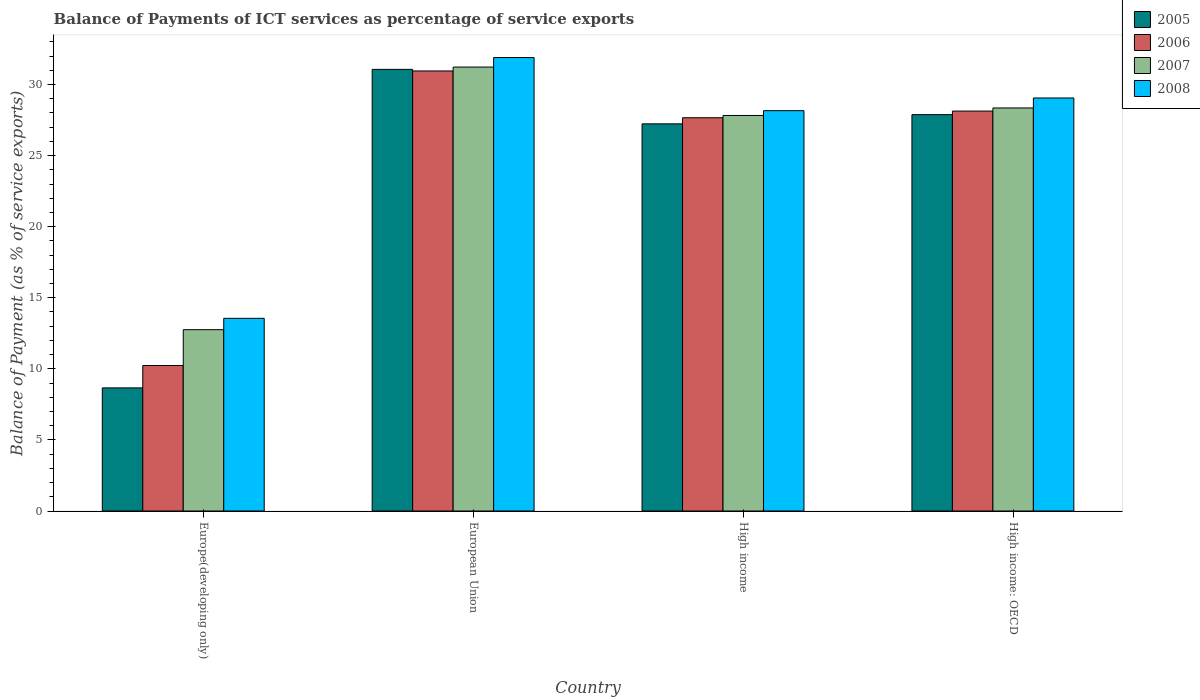How many groups of bars are there?
Your response must be concise. 4. How many bars are there on the 3rd tick from the right?
Provide a short and direct response. 4. In how many cases, is the number of bars for a given country not equal to the number of legend labels?
Offer a very short reply. 0. What is the balance of payments of ICT services in 2005 in High income: OECD?
Your answer should be compact. 27.88. Across all countries, what is the maximum balance of payments of ICT services in 2005?
Ensure brevity in your answer.  31.07. Across all countries, what is the minimum balance of payments of ICT services in 2006?
Keep it short and to the point. 10.24. In which country was the balance of payments of ICT services in 2006 minimum?
Make the answer very short. Europe(developing only). What is the total balance of payments of ICT services in 2005 in the graph?
Provide a succinct answer. 94.85. What is the difference between the balance of payments of ICT services in 2006 in Europe(developing only) and that in High income: OECD?
Provide a succinct answer. -17.9. What is the difference between the balance of payments of ICT services in 2006 in High income and the balance of payments of ICT services in 2007 in European Union?
Provide a succinct answer. -3.56. What is the average balance of payments of ICT services in 2008 per country?
Your response must be concise. 25.67. What is the difference between the balance of payments of ICT services of/in 2005 and balance of payments of ICT services of/in 2007 in Europe(developing only)?
Your response must be concise. -4.1. In how many countries, is the balance of payments of ICT services in 2008 greater than 9 %?
Your response must be concise. 4. What is the ratio of the balance of payments of ICT services in 2007 in European Union to that in High income?
Your answer should be compact. 1.12. What is the difference between the highest and the second highest balance of payments of ICT services in 2006?
Provide a succinct answer. -0.47. What is the difference between the highest and the lowest balance of payments of ICT services in 2006?
Give a very brief answer. 20.72. What does the 1st bar from the left in Europe(developing only) represents?
Your answer should be very brief. 2005. Are all the bars in the graph horizontal?
Provide a succinct answer. No. What is the difference between two consecutive major ticks on the Y-axis?
Provide a succinct answer. 5. Are the values on the major ticks of Y-axis written in scientific E-notation?
Make the answer very short. No. Does the graph contain grids?
Your answer should be very brief. No. Where does the legend appear in the graph?
Make the answer very short. Top right. How many legend labels are there?
Provide a succinct answer. 4. What is the title of the graph?
Keep it short and to the point. Balance of Payments of ICT services as percentage of service exports. Does "1970" appear as one of the legend labels in the graph?
Keep it short and to the point. No. What is the label or title of the Y-axis?
Your answer should be very brief. Balance of Payment (as % of service exports). What is the Balance of Payment (as % of service exports) of 2005 in Europe(developing only)?
Your response must be concise. 8.66. What is the Balance of Payment (as % of service exports) in 2006 in Europe(developing only)?
Provide a short and direct response. 10.24. What is the Balance of Payment (as % of service exports) in 2007 in Europe(developing only)?
Your response must be concise. 12.76. What is the Balance of Payment (as % of service exports) in 2008 in Europe(developing only)?
Provide a short and direct response. 13.56. What is the Balance of Payment (as % of service exports) of 2005 in European Union?
Give a very brief answer. 31.07. What is the Balance of Payment (as % of service exports) in 2006 in European Union?
Your answer should be compact. 30.96. What is the Balance of Payment (as % of service exports) in 2007 in European Union?
Your response must be concise. 31.23. What is the Balance of Payment (as % of service exports) of 2008 in European Union?
Offer a terse response. 31.9. What is the Balance of Payment (as % of service exports) of 2005 in High income?
Your answer should be compact. 27.24. What is the Balance of Payment (as % of service exports) in 2006 in High income?
Make the answer very short. 27.67. What is the Balance of Payment (as % of service exports) in 2007 in High income?
Provide a short and direct response. 27.83. What is the Balance of Payment (as % of service exports) in 2008 in High income?
Your answer should be compact. 28.16. What is the Balance of Payment (as % of service exports) in 2005 in High income: OECD?
Offer a terse response. 27.88. What is the Balance of Payment (as % of service exports) of 2006 in High income: OECD?
Your answer should be compact. 28.13. What is the Balance of Payment (as % of service exports) in 2007 in High income: OECD?
Your response must be concise. 28.35. What is the Balance of Payment (as % of service exports) in 2008 in High income: OECD?
Give a very brief answer. 29.06. Across all countries, what is the maximum Balance of Payment (as % of service exports) in 2005?
Your response must be concise. 31.07. Across all countries, what is the maximum Balance of Payment (as % of service exports) in 2006?
Your answer should be compact. 30.96. Across all countries, what is the maximum Balance of Payment (as % of service exports) in 2007?
Your answer should be compact. 31.23. Across all countries, what is the maximum Balance of Payment (as % of service exports) of 2008?
Your response must be concise. 31.9. Across all countries, what is the minimum Balance of Payment (as % of service exports) in 2005?
Make the answer very short. 8.66. Across all countries, what is the minimum Balance of Payment (as % of service exports) in 2006?
Your answer should be very brief. 10.24. Across all countries, what is the minimum Balance of Payment (as % of service exports) in 2007?
Provide a short and direct response. 12.76. Across all countries, what is the minimum Balance of Payment (as % of service exports) of 2008?
Ensure brevity in your answer.  13.56. What is the total Balance of Payment (as % of service exports) in 2005 in the graph?
Make the answer very short. 94.85. What is the total Balance of Payment (as % of service exports) in 2006 in the graph?
Offer a terse response. 96.99. What is the total Balance of Payment (as % of service exports) of 2007 in the graph?
Ensure brevity in your answer.  100.17. What is the total Balance of Payment (as % of service exports) of 2008 in the graph?
Your answer should be very brief. 102.68. What is the difference between the Balance of Payment (as % of service exports) in 2005 in Europe(developing only) and that in European Union?
Your answer should be compact. -22.41. What is the difference between the Balance of Payment (as % of service exports) of 2006 in Europe(developing only) and that in European Union?
Give a very brief answer. -20.72. What is the difference between the Balance of Payment (as % of service exports) in 2007 in Europe(developing only) and that in European Union?
Your answer should be compact. -18.47. What is the difference between the Balance of Payment (as % of service exports) of 2008 in Europe(developing only) and that in European Union?
Your response must be concise. -18.35. What is the difference between the Balance of Payment (as % of service exports) in 2005 in Europe(developing only) and that in High income?
Your response must be concise. -18.57. What is the difference between the Balance of Payment (as % of service exports) of 2006 in Europe(developing only) and that in High income?
Offer a very short reply. -17.43. What is the difference between the Balance of Payment (as % of service exports) of 2007 in Europe(developing only) and that in High income?
Give a very brief answer. -15.07. What is the difference between the Balance of Payment (as % of service exports) of 2008 in Europe(developing only) and that in High income?
Make the answer very short. -14.61. What is the difference between the Balance of Payment (as % of service exports) of 2005 in Europe(developing only) and that in High income: OECD?
Provide a short and direct response. -19.22. What is the difference between the Balance of Payment (as % of service exports) of 2006 in Europe(developing only) and that in High income: OECD?
Keep it short and to the point. -17.9. What is the difference between the Balance of Payment (as % of service exports) of 2007 in Europe(developing only) and that in High income: OECD?
Offer a very short reply. -15.6. What is the difference between the Balance of Payment (as % of service exports) in 2008 in Europe(developing only) and that in High income: OECD?
Offer a very short reply. -15.5. What is the difference between the Balance of Payment (as % of service exports) in 2005 in European Union and that in High income?
Give a very brief answer. 3.83. What is the difference between the Balance of Payment (as % of service exports) of 2006 in European Union and that in High income?
Your response must be concise. 3.29. What is the difference between the Balance of Payment (as % of service exports) of 2007 in European Union and that in High income?
Give a very brief answer. 3.41. What is the difference between the Balance of Payment (as % of service exports) in 2008 in European Union and that in High income?
Your answer should be very brief. 3.74. What is the difference between the Balance of Payment (as % of service exports) in 2005 in European Union and that in High income: OECD?
Offer a very short reply. 3.19. What is the difference between the Balance of Payment (as % of service exports) of 2006 in European Union and that in High income: OECD?
Provide a short and direct response. 2.82. What is the difference between the Balance of Payment (as % of service exports) of 2007 in European Union and that in High income: OECD?
Offer a very short reply. 2.88. What is the difference between the Balance of Payment (as % of service exports) of 2008 in European Union and that in High income: OECD?
Make the answer very short. 2.84. What is the difference between the Balance of Payment (as % of service exports) of 2005 in High income and that in High income: OECD?
Keep it short and to the point. -0.65. What is the difference between the Balance of Payment (as % of service exports) of 2006 in High income and that in High income: OECD?
Offer a very short reply. -0.47. What is the difference between the Balance of Payment (as % of service exports) in 2007 in High income and that in High income: OECD?
Ensure brevity in your answer.  -0.53. What is the difference between the Balance of Payment (as % of service exports) in 2008 in High income and that in High income: OECD?
Keep it short and to the point. -0.89. What is the difference between the Balance of Payment (as % of service exports) in 2005 in Europe(developing only) and the Balance of Payment (as % of service exports) in 2006 in European Union?
Keep it short and to the point. -22.3. What is the difference between the Balance of Payment (as % of service exports) of 2005 in Europe(developing only) and the Balance of Payment (as % of service exports) of 2007 in European Union?
Offer a very short reply. -22.57. What is the difference between the Balance of Payment (as % of service exports) of 2005 in Europe(developing only) and the Balance of Payment (as % of service exports) of 2008 in European Union?
Give a very brief answer. -23.24. What is the difference between the Balance of Payment (as % of service exports) of 2006 in Europe(developing only) and the Balance of Payment (as % of service exports) of 2007 in European Union?
Ensure brevity in your answer.  -21. What is the difference between the Balance of Payment (as % of service exports) of 2006 in Europe(developing only) and the Balance of Payment (as % of service exports) of 2008 in European Union?
Give a very brief answer. -21.66. What is the difference between the Balance of Payment (as % of service exports) of 2007 in Europe(developing only) and the Balance of Payment (as % of service exports) of 2008 in European Union?
Make the answer very short. -19.14. What is the difference between the Balance of Payment (as % of service exports) in 2005 in Europe(developing only) and the Balance of Payment (as % of service exports) in 2006 in High income?
Your response must be concise. -19.01. What is the difference between the Balance of Payment (as % of service exports) in 2005 in Europe(developing only) and the Balance of Payment (as % of service exports) in 2007 in High income?
Your answer should be compact. -19.16. What is the difference between the Balance of Payment (as % of service exports) of 2005 in Europe(developing only) and the Balance of Payment (as % of service exports) of 2008 in High income?
Make the answer very short. -19.5. What is the difference between the Balance of Payment (as % of service exports) of 2006 in Europe(developing only) and the Balance of Payment (as % of service exports) of 2007 in High income?
Provide a short and direct response. -17.59. What is the difference between the Balance of Payment (as % of service exports) in 2006 in Europe(developing only) and the Balance of Payment (as % of service exports) in 2008 in High income?
Provide a succinct answer. -17.93. What is the difference between the Balance of Payment (as % of service exports) of 2007 in Europe(developing only) and the Balance of Payment (as % of service exports) of 2008 in High income?
Give a very brief answer. -15.41. What is the difference between the Balance of Payment (as % of service exports) of 2005 in Europe(developing only) and the Balance of Payment (as % of service exports) of 2006 in High income: OECD?
Your answer should be very brief. -19.47. What is the difference between the Balance of Payment (as % of service exports) of 2005 in Europe(developing only) and the Balance of Payment (as % of service exports) of 2007 in High income: OECD?
Provide a succinct answer. -19.69. What is the difference between the Balance of Payment (as % of service exports) in 2005 in Europe(developing only) and the Balance of Payment (as % of service exports) in 2008 in High income: OECD?
Offer a terse response. -20.39. What is the difference between the Balance of Payment (as % of service exports) in 2006 in Europe(developing only) and the Balance of Payment (as % of service exports) in 2007 in High income: OECD?
Offer a terse response. -18.12. What is the difference between the Balance of Payment (as % of service exports) of 2006 in Europe(developing only) and the Balance of Payment (as % of service exports) of 2008 in High income: OECD?
Keep it short and to the point. -18.82. What is the difference between the Balance of Payment (as % of service exports) of 2007 in Europe(developing only) and the Balance of Payment (as % of service exports) of 2008 in High income: OECD?
Keep it short and to the point. -16.3. What is the difference between the Balance of Payment (as % of service exports) of 2005 in European Union and the Balance of Payment (as % of service exports) of 2006 in High income?
Ensure brevity in your answer.  3.4. What is the difference between the Balance of Payment (as % of service exports) in 2005 in European Union and the Balance of Payment (as % of service exports) in 2007 in High income?
Provide a short and direct response. 3.24. What is the difference between the Balance of Payment (as % of service exports) in 2005 in European Union and the Balance of Payment (as % of service exports) in 2008 in High income?
Offer a very short reply. 2.91. What is the difference between the Balance of Payment (as % of service exports) of 2006 in European Union and the Balance of Payment (as % of service exports) of 2007 in High income?
Offer a very short reply. 3.13. What is the difference between the Balance of Payment (as % of service exports) in 2006 in European Union and the Balance of Payment (as % of service exports) in 2008 in High income?
Make the answer very short. 2.79. What is the difference between the Balance of Payment (as % of service exports) in 2007 in European Union and the Balance of Payment (as % of service exports) in 2008 in High income?
Your answer should be compact. 3.07. What is the difference between the Balance of Payment (as % of service exports) of 2005 in European Union and the Balance of Payment (as % of service exports) of 2006 in High income: OECD?
Make the answer very short. 2.93. What is the difference between the Balance of Payment (as % of service exports) in 2005 in European Union and the Balance of Payment (as % of service exports) in 2007 in High income: OECD?
Keep it short and to the point. 2.72. What is the difference between the Balance of Payment (as % of service exports) in 2005 in European Union and the Balance of Payment (as % of service exports) in 2008 in High income: OECD?
Offer a very short reply. 2.01. What is the difference between the Balance of Payment (as % of service exports) in 2006 in European Union and the Balance of Payment (as % of service exports) in 2007 in High income: OECD?
Ensure brevity in your answer.  2.6. What is the difference between the Balance of Payment (as % of service exports) of 2006 in European Union and the Balance of Payment (as % of service exports) of 2008 in High income: OECD?
Ensure brevity in your answer.  1.9. What is the difference between the Balance of Payment (as % of service exports) of 2007 in European Union and the Balance of Payment (as % of service exports) of 2008 in High income: OECD?
Keep it short and to the point. 2.18. What is the difference between the Balance of Payment (as % of service exports) in 2005 in High income and the Balance of Payment (as % of service exports) in 2006 in High income: OECD?
Your answer should be compact. -0.9. What is the difference between the Balance of Payment (as % of service exports) of 2005 in High income and the Balance of Payment (as % of service exports) of 2007 in High income: OECD?
Offer a very short reply. -1.12. What is the difference between the Balance of Payment (as % of service exports) of 2005 in High income and the Balance of Payment (as % of service exports) of 2008 in High income: OECD?
Your answer should be compact. -1.82. What is the difference between the Balance of Payment (as % of service exports) of 2006 in High income and the Balance of Payment (as % of service exports) of 2007 in High income: OECD?
Your answer should be very brief. -0.69. What is the difference between the Balance of Payment (as % of service exports) in 2006 in High income and the Balance of Payment (as % of service exports) in 2008 in High income: OECD?
Make the answer very short. -1.39. What is the difference between the Balance of Payment (as % of service exports) of 2007 in High income and the Balance of Payment (as % of service exports) of 2008 in High income: OECD?
Offer a very short reply. -1.23. What is the average Balance of Payment (as % of service exports) of 2005 per country?
Your answer should be very brief. 23.71. What is the average Balance of Payment (as % of service exports) in 2006 per country?
Make the answer very short. 24.25. What is the average Balance of Payment (as % of service exports) of 2007 per country?
Your answer should be compact. 25.04. What is the average Balance of Payment (as % of service exports) in 2008 per country?
Your answer should be compact. 25.67. What is the difference between the Balance of Payment (as % of service exports) in 2005 and Balance of Payment (as % of service exports) in 2006 in Europe(developing only)?
Provide a short and direct response. -1.57. What is the difference between the Balance of Payment (as % of service exports) in 2005 and Balance of Payment (as % of service exports) in 2007 in Europe(developing only)?
Give a very brief answer. -4.1. What is the difference between the Balance of Payment (as % of service exports) of 2005 and Balance of Payment (as % of service exports) of 2008 in Europe(developing only)?
Give a very brief answer. -4.89. What is the difference between the Balance of Payment (as % of service exports) of 2006 and Balance of Payment (as % of service exports) of 2007 in Europe(developing only)?
Give a very brief answer. -2.52. What is the difference between the Balance of Payment (as % of service exports) of 2006 and Balance of Payment (as % of service exports) of 2008 in Europe(developing only)?
Offer a very short reply. -3.32. What is the difference between the Balance of Payment (as % of service exports) in 2007 and Balance of Payment (as % of service exports) in 2008 in Europe(developing only)?
Provide a short and direct response. -0.8. What is the difference between the Balance of Payment (as % of service exports) in 2005 and Balance of Payment (as % of service exports) in 2006 in European Union?
Offer a terse response. 0.11. What is the difference between the Balance of Payment (as % of service exports) in 2005 and Balance of Payment (as % of service exports) in 2007 in European Union?
Provide a succinct answer. -0.16. What is the difference between the Balance of Payment (as % of service exports) in 2005 and Balance of Payment (as % of service exports) in 2008 in European Union?
Offer a very short reply. -0.83. What is the difference between the Balance of Payment (as % of service exports) of 2006 and Balance of Payment (as % of service exports) of 2007 in European Union?
Provide a short and direct response. -0.27. What is the difference between the Balance of Payment (as % of service exports) in 2006 and Balance of Payment (as % of service exports) in 2008 in European Union?
Make the answer very short. -0.94. What is the difference between the Balance of Payment (as % of service exports) in 2007 and Balance of Payment (as % of service exports) in 2008 in European Union?
Ensure brevity in your answer.  -0.67. What is the difference between the Balance of Payment (as % of service exports) in 2005 and Balance of Payment (as % of service exports) in 2006 in High income?
Offer a terse response. -0.43. What is the difference between the Balance of Payment (as % of service exports) of 2005 and Balance of Payment (as % of service exports) of 2007 in High income?
Ensure brevity in your answer.  -0.59. What is the difference between the Balance of Payment (as % of service exports) of 2005 and Balance of Payment (as % of service exports) of 2008 in High income?
Provide a short and direct response. -0.93. What is the difference between the Balance of Payment (as % of service exports) of 2006 and Balance of Payment (as % of service exports) of 2007 in High income?
Ensure brevity in your answer.  -0.16. What is the difference between the Balance of Payment (as % of service exports) of 2006 and Balance of Payment (as % of service exports) of 2008 in High income?
Offer a terse response. -0.5. What is the difference between the Balance of Payment (as % of service exports) in 2007 and Balance of Payment (as % of service exports) in 2008 in High income?
Provide a short and direct response. -0.34. What is the difference between the Balance of Payment (as % of service exports) in 2005 and Balance of Payment (as % of service exports) in 2006 in High income: OECD?
Offer a terse response. -0.25. What is the difference between the Balance of Payment (as % of service exports) in 2005 and Balance of Payment (as % of service exports) in 2007 in High income: OECD?
Make the answer very short. -0.47. What is the difference between the Balance of Payment (as % of service exports) in 2005 and Balance of Payment (as % of service exports) in 2008 in High income: OECD?
Ensure brevity in your answer.  -1.17. What is the difference between the Balance of Payment (as % of service exports) in 2006 and Balance of Payment (as % of service exports) in 2007 in High income: OECD?
Provide a short and direct response. -0.22. What is the difference between the Balance of Payment (as % of service exports) of 2006 and Balance of Payment (as % of service exports) of 2008 in High income: OECD?
Offer a very short reply. -0.92. What is the difference between the Balance of Payment (as % of service exports) of 2007 and Balance of Payment (as % of service exports) of 2008 in High income: OECD?
Your answer should be very brief. -0.7. What is the ratio of the Balance of Payment (as % of service exports) in 2005 in Europe(developing only) to that in European Union?
Provide a short and direct response. 0.28. What is the ratio of the Balance of Payment (as % of service exports) in 2006 in Europe(developing only) to that in European Union?
Your answer should be very brief. 0.33. What is the ratio of the Balance of Payment (as % of service exports) of 2007 in Europe(developing only) to that in European Union?
Offer a terse response. 0.41. What is the ratio of the Balance of Payment (as % of service exports) in 2008 in Europe(developing only) to that in European Union?
Provide a short and direct response. 0.42. What is the ratio of the Balance of Payment (as % of service exports) of 2005 in Europe(developing only) to that in High income?
Give a very brief answer. 0.32. What is the ratio of the Balance of Payment (as % of service exports) in 2006 in Europe(developing only) to that in High income?
Your response must be concise. 0.37. What is the ratio of the Balance of Payment (as % of service exports) in 2007 in Europe(developing only) to that in High income?
Provide a succinct answer. 0.46. What is the ratio of the Balance of Payment (as % of service exports) in 2008 in Europe(developing only) to that in High income?
Offer a terse response. 0.48. What is the ratio of the Balance of Payment (as % of service exports) in 2005 in Europe(developing only) to that in High income: OECD?
Your response must be concise. 0.31. What is the ratio of the Balance of Payment (as % of service exports) in 2006 in Europe(developing only) to that in High income: OECD?
Your answer should be compact. 0.36. What is the ratio of the Balance of Payment (as % of service exports) in 2007 in Europe(developing only) to that in High income: OECD?
Provide a succinct answer. 0.45. What is the ratio of the Balance of Payment (as % of service exports) of 2008 in Europe(developing only) to that in High income: OECD?
Your answer should be compact. 0.47. What is the ratio of the Balance of Payment (as % of service exports) of 2005 in European Union to that in High income?
Offer a very short reply. 1.14. What is the ratio of the Balance of Payment (as % of service exports) in 2006 in European Union to that in High income?
Provide a short and direct response. 1.12. What is the ratio of the Balance of Payment (as % of service exports) of 2007 in European Union to that in High income?
Your answer should be compact. 1.12. What is the ratio of the Balance of Payment (as % of service exports) in 2008 in European Union to that in High income?
Keep it short and to the point. 1.13. What is the ratio of the Balance of Payment (as % of service exports) of 2005 in European Union to that in High income: OECD?
Give a very brief answer. 1.11. What is the ratio of the Balance of Payment (as % of service exports) of 2006 in European Union to that in High income: OECD?
Your answer should be very brief. 1.1. What is the ratio of the Balance of Payment (as % of service exports) in 2007 in European Union to that in High income: OECD?
Offer a very short reply. 1.1. What is the ratio of the Balance of Payment (as % of service exports) in 2008 in European Union to that in High income: OECD?
Offer a terse response. 1.1. What is the ratio of the Balance of Payment (as % of service exports) in 2005 in High income to that in High income: OECD?
Keep it short and to the point. 0.98. What is the ratio of the Balance of Payment (as % of service exports) in 2006 in High income to that in High income: OECD?
Provide a short and direct response. 0.98. What is the ratio of the Balance of Payment (as % of service exports) of 2007 in High income to that in High income: OECD?
Provide a succinct answer. 0.98. What is the ratio of the Balance of Payment (as % of service exports) in 2008 in High income to that in High income: OECD?
Offer a terse response. 0.97. What is the difference between the highest and the second highest Balance of Payment (as % of service exports) of 2005?
Provide a short and direct response. 3.19. What is the difference between the highest and the second highest Balance of Payment (as % of service exports) of 2006?
Provide a succinct answer. 2.82. What is the difference between the highest and the second highest Balance of Payment (as % of service exports) in 2007?
Your answer should be compact. 2.88. What is the difference between the highest and the second highest Balance of Payment (as % of service exports) of 2008?
Your answer should be very brief. 2.84. What is the difference between the highest and the lowest Balance of Payment (as % of service exports) in 2005?
Your response must be concise. 22.41. What is the difference between the highest and the lowest Balance of Payment (as % of service exports) of 2006?
Provide a succinct answer. 20.72. What is the difference between the highest and the lowest Balance of Payment (as % of service exports) in 2007?
Offer a very short reply. 18.47. What is the difference between the highest and the lowest Balance of Payment (as % of service exports) in 2008?
Provide a succinct answer. 18.35. 